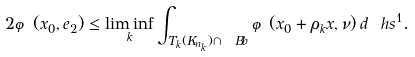Convert formula to latex. <formula><loc_0><loc_0><loc_500><loc_500>2 \varphi ( x _ { 0 } , e _ { 2 } ) \leq \liminf _ { k } \int _ { T _ { k } ( K _ { n _ { k } } ) \cap \ B b } \varphi ( x _ { 0 } + \rho _ { k } x , \nu ) \, d \ h s ^ { 1 } .</formula> 